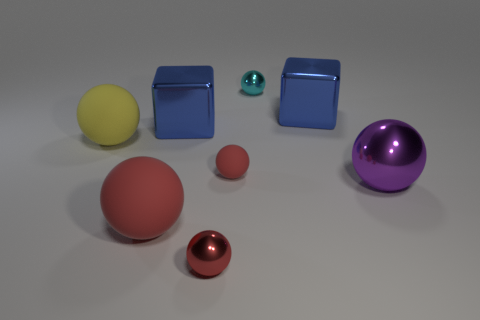There is a matte object that is the same color as the small matte ball; what is its shape?
Keep it short and to the point. Sphere. Is there any other thing that is the same color as the large metallic ball?
Offer a very short reply. No. What is the shape of the tiny thing that is made of the same material as the small cyan ball?
Offer a very short reply. Sphere. There is a large ball that is on the right side of the tiny shiny ball that is behind the small matte thing; how many tiny red objects are behind it?
Give a very brief answer. 1. There is a red thing that is both to the right of the large red matte object and in front of the big shiny ball; what shape is it?
Provide a short and direct response. Sphere. Is the number of big yellow spheres right of the yellow sphere less than the number of large metal things?
Offer a very short reply. Yes. How many tiny things are blue metallic cubes or cyan objects?
Your answer should be compact. 1. What size is the purple metal sphere?
Provide a succinct answer. Large. There is a yellow rubber ball; how many big purple metal things are right of it?
Provide a succinct answer. 1. There is a cyan thing that is the same shape as the large yellow thing; what is its size?
Your answer should be very brief. Small. 